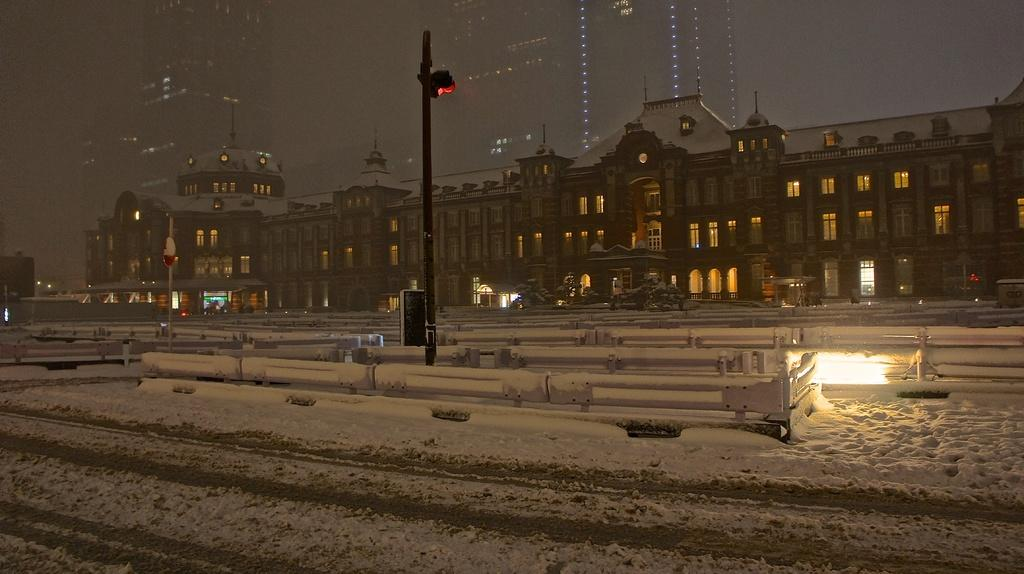What type of structures can be seen in the image? There are buildings in the image. What other natural elements are present in the image? There are trees in the image. What type of man-made structures can be seen in the image? There are roads in the image. How is the weather depicted in the image? The roads are covered with snow, indicating a snowy condition. Can you see any goats on the island in the image? There is no island present in the image, and therefore no goats can be seen. What causes the burst of color in the image? There is no burst of color mentioned in the image; it is described as having buildings, trees, roads, and snow. 